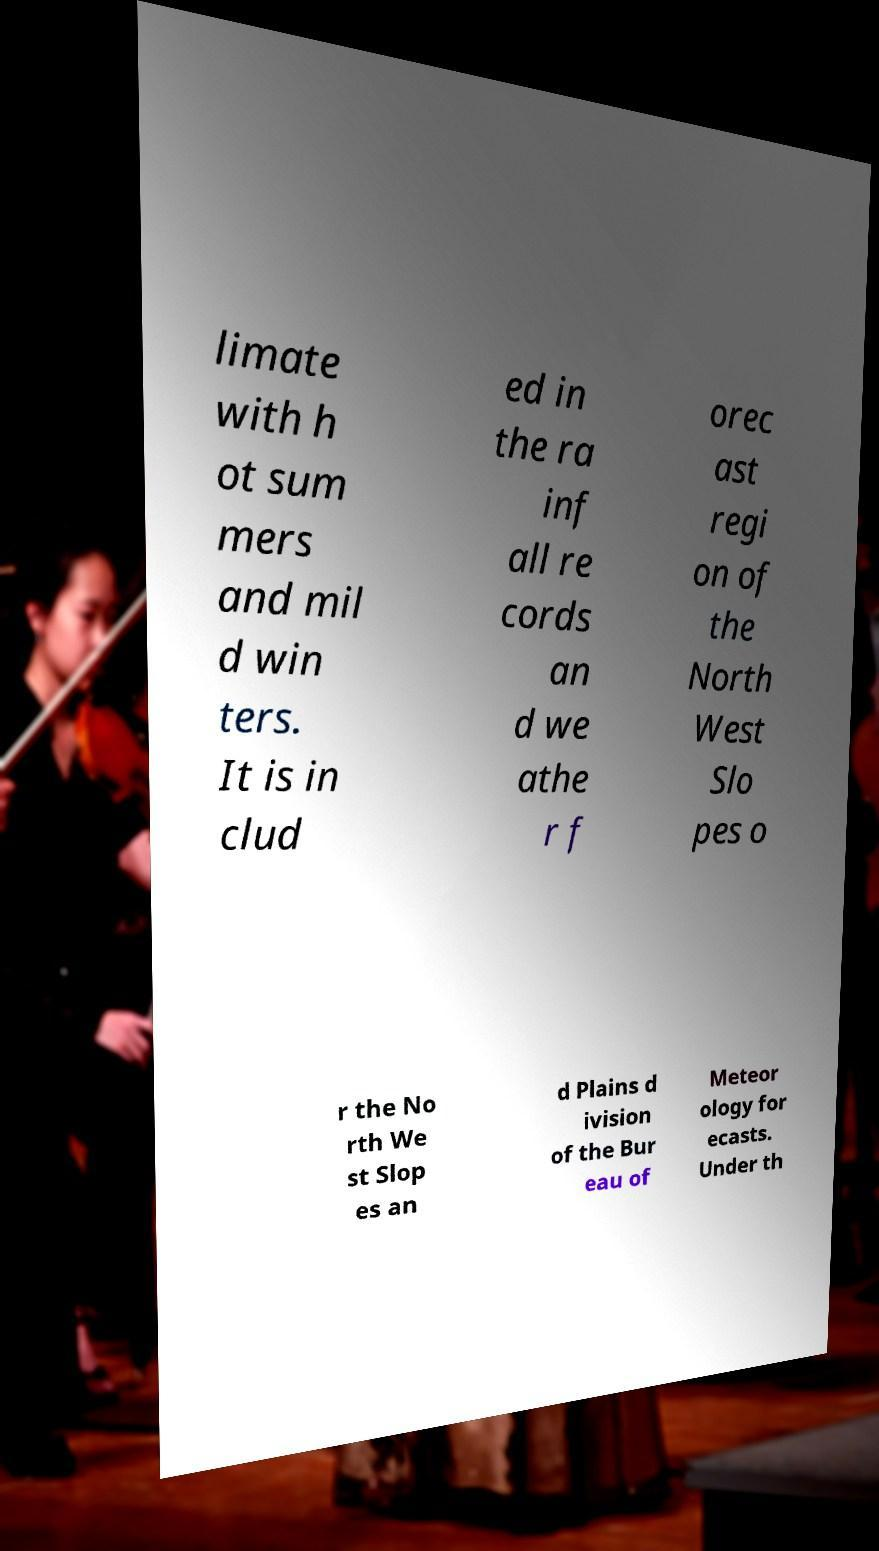What messages or text are displayed in this image? I need them in a readable, typed format. limate with h ot sum mers and mil d win ters. It is in clud ed in the ra inf all re cords an d we athe r f orec ast regi on of the North West Slo pes o r the No rth We st Slop es an d Plains d ivision of the Bur eau of Meteor ology for ecasts. Under th 